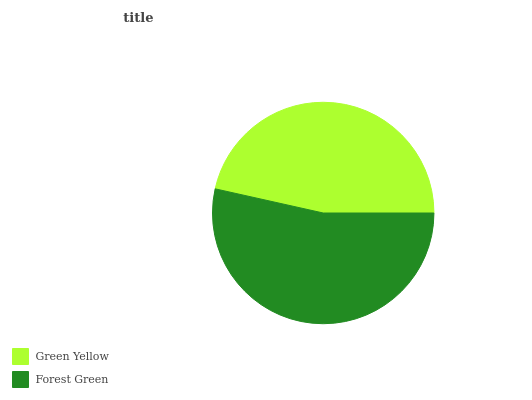Is Green Yellow the minimum?
Answer yes or no. Yes. Is Forest Green the maximum?
Answer yes or no. Yes. Is Forest Green the minimum?
Answer yes or no. No. Is Forest Green greater than Green Yellow?
Answer yes or no. Yes. Is Green Yellow less than Forest Green?
Answer yes or no. Yes. Is Green Yellow greater than Forest Green?
Answer yes or no. No. Is Forest Green less than Green Yellow?
Answer yes or no. No. Is Forest Green the high median?
Answer yes or no. Yes. Is Green Yellow the low median?
Answer yes or no. Yes. Is Green Yellow the high median?
Answer yes or no. No. Is Forest Green the low median?
Answer yes or no. No. 